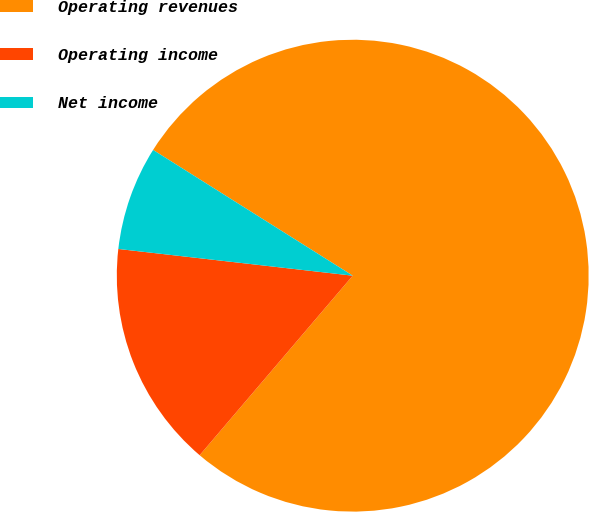<chart> <loc_0><loc_0><loc_500><loc_500><pie_chart><fcel>Operating revenues<fcel>Operating income<fcel>Net income<nl><fcel>77.29%<fcel>15.57%<fcel>7.14%<nl></chart> 